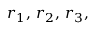<formula> <loc_0><loc_0><loc_500><loc_500>r _ { 1 } , \, r _ { 2 } , \, r _ { 3 } ,</formula> 